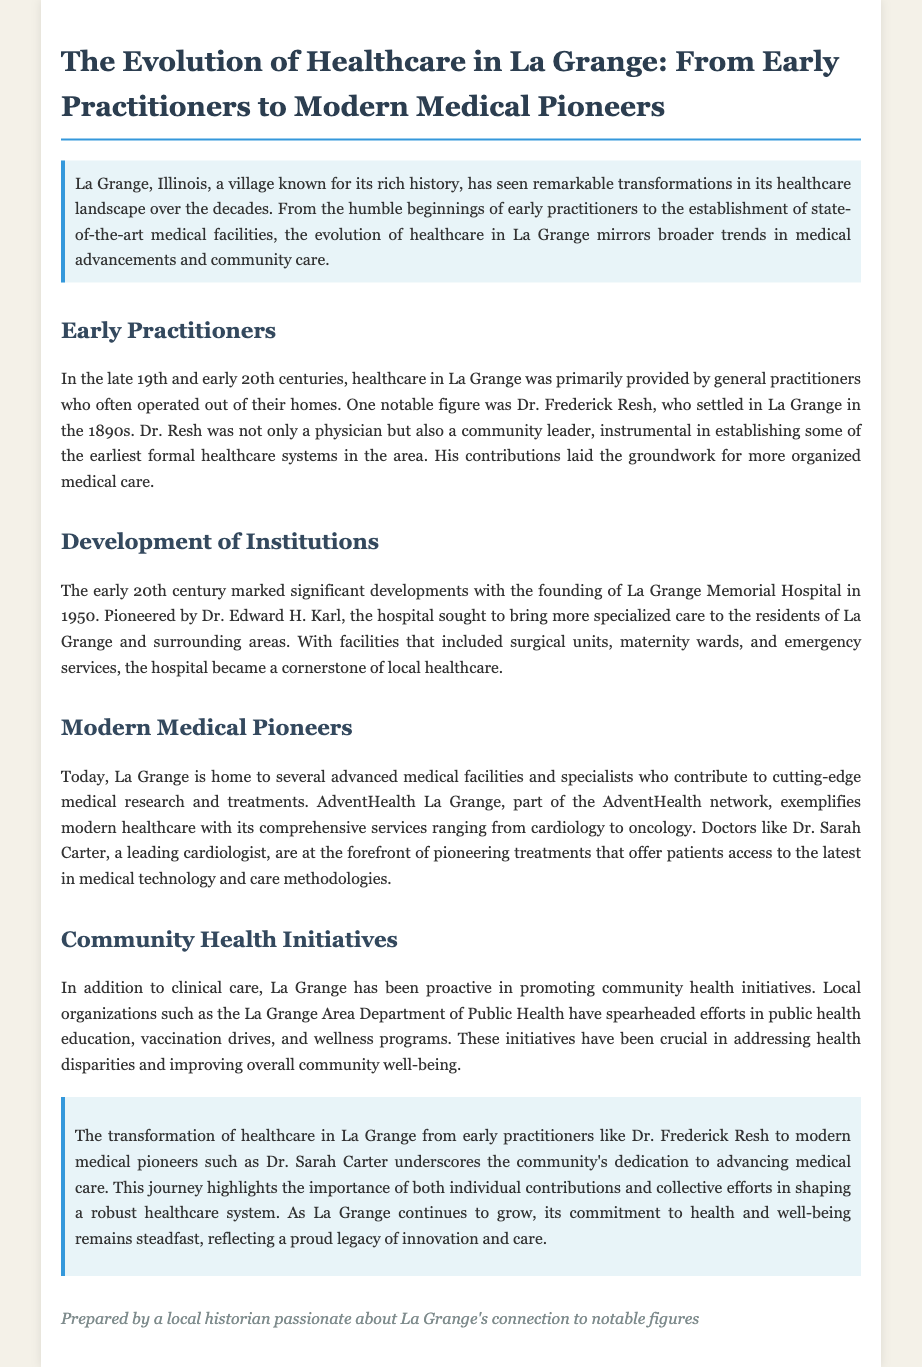What notable figure settled in La Grange in the 1890s? The document mentions Dr. Frederick Resh as the notable figure who settled in La Grange in the 1890s.
Answer: Dr. Frederick Resh When was La Grange Memorial Hospital founded? The document states that La Grange Memorial Hospital was founded in 1950.
Answer: 1950 Who pioneered La Grange Memorial Hospital? The document indicates that Dr. Edward H. Karl was the pioneer behind the establishment of La Grange Memorial Hospital.
Answer: Dr. Edward H. Karl What type of facility is AdventHealth La Grange? The document describes AdventHealth La Grange as an advanced medical facility providing comprehensive services.
Answer: Advanced medical facility What initiative has the La Grange Area Department of Public Health spearheaded? The document mentions that the La Grange Area Department of Public Health has led efforts in public health education.
Answer: Public health education What is the primary focus of healthcare advancements in La Grange as mentioned in the document? The document suggests that healthcare advancements in La Grange reflect broader trends in medical advancements and community care.
Answer: Medical advancements and community care Who is a leading cardiologist mentioned in the document? The document identifies Dr. Sarah Carter as a leading cardiologist in La Grange.
Answer: Dr. Sarah Carter What kind of health programs has La Grange been proactive in promoting? The document states that La Grange has been active in wellness programs as part of its community health initiatives.
Answer: Wellness programs What is a key takeaway from the document regarding the evolution of healthcare in La Grange? The document highlights the importance of both individual contributions and collective efforts in shaping a robust healthcare system.
Answer: Individual contributions and collective efforts 